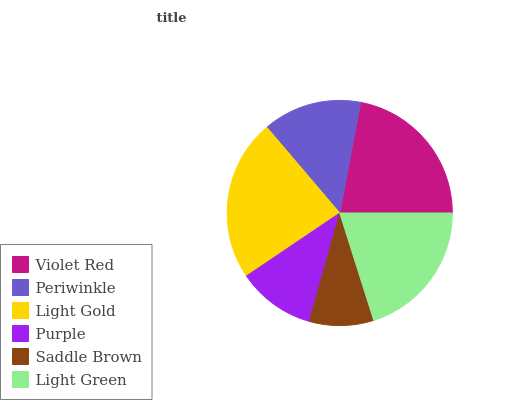Is Saddle Brown the minimum?
Answer yes or no. Yes. Is Light Gold the maximum?
Answer yes or no. Yes. Is Periwinkle the minimum?
Answer yes or no. No. Is Periwinkle the maximum?
Answer yes or no. No. Is Violet Red greater than Periwinkle?
Answer yes or no. Yes. Is Periwinkle less than Violet Red?
Answer yes or no. Yes. Is Periwinkle greater than Violet Red?
Answer yes or no. No. Is Violet Red less than Periwinkle?
Answer yes or no. No. Is Light Green the high median?
Answer yes or no. Yes. Is Periwinkle the low median?
Answer yes or no. Yes. Is Saddle Brown the high median?
Answer yes or no. No. Is Violet Red the low median?
Answer yes or no. No. 